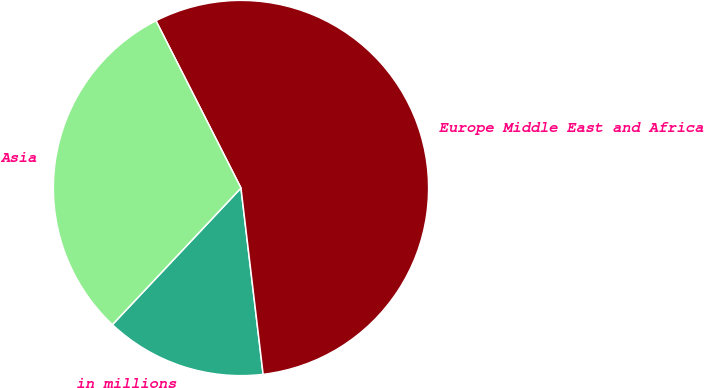<chart> <loc_0><loc_0><loc_500><loc_500><pie_chart><fcel>in millions<fcel>Europe Middle East and Africa<fcel>Asia<nl><fcel>13.9%<fcel>55.6%<fcel>30.5%<nl></chart> 